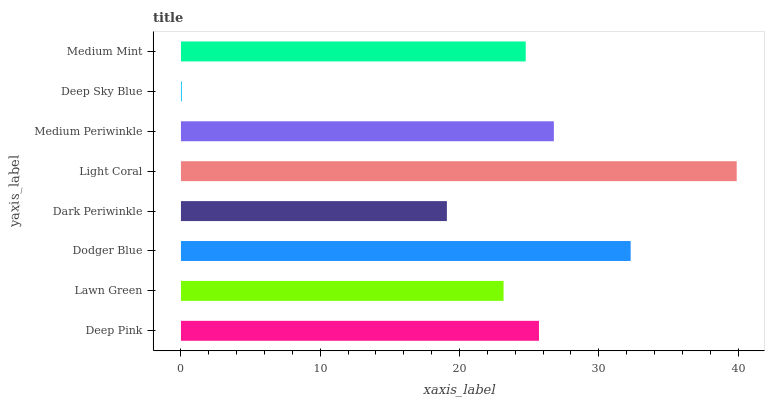Is Deep Sky Blue the minimum?
Answer yes or no. Yes. Is Light Coral the maximum?
Answer yes or no. Yes. Is Lawn Green the minimum?
Answer yes or no. No. Is Lawn Green the maximum?
Answer yes or no. No. Is Deep Pink greater than Lawn Green?
Answer yes or no. Yes. Is Lawn Green less than Deep Pink?
Answer yes or no. Yes. Is Lawn Green greater than Deep Pink?
Answer yes or no. No. Is Deep Pink less than Lawn Green?
Answer yes or no. No. Is Deep Pink the high median?
Answer yes or no. Yes. Is Medium Mint the low median?
Answer yes or no. Yes. Is Lawn Green the high median?
Answer yes or no. No. Is Dark Periwinkle the low median?
Answer yes or no. No. 